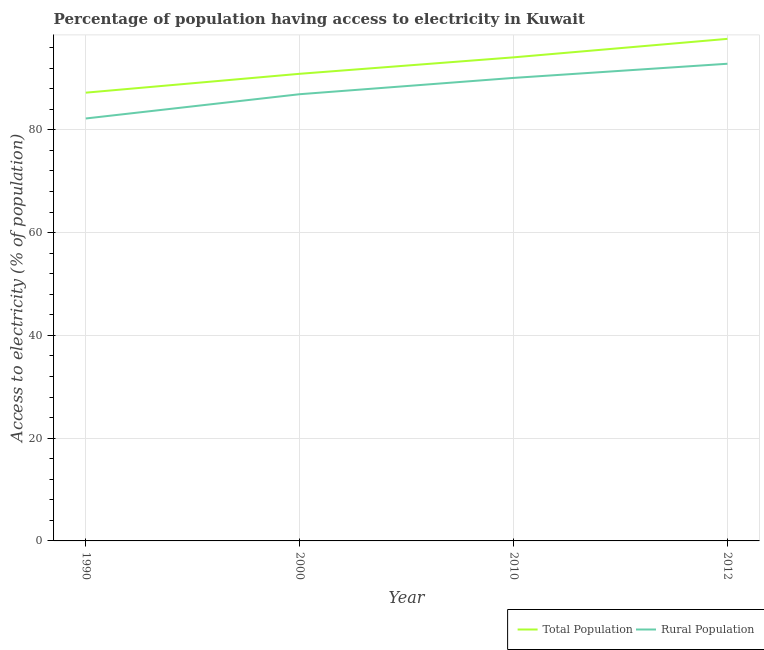Does the line corresponding to percentage of population having access to electricity intersect with the line corresponding to percentage of rural population having access to electricity?
Make the answer very short. No. Is the number of lines equal to the number of legend labels?
Offer a very short reply. Yes. What is the percentage of population having access to electricity in 2010?
Your answer should be very brief. 94.1. Across all years, what is the maximum percentage of rural population having access to electricity?
Offer a terse response. 92.85. Across all years, what is the minimum percentage of population having access to electricity?
Make the answer very short. 87.23. In which year was the percentage of population having access to electricity minimum?
Provide a short and direct response. 1990. What is the total percentage of population having access to electricity in the graph?
Offer a terse response. 369.92. What is the difference between the percentage of population having access to electricity in 1990 and that in 2010?
Offer a terse response. -6.87. What is the difference between the percentage of population having access to electricity in 2000 and the percentage of rural population having access to electricity in 2012?
Keep it short and to the point. -1.96. What is the average percentage of rural population having access to electricity per year?
Ensure brevity in your answer.  88.02. In the year 2000, what is the difference between the percentage of population having access to electricity and percentage of rural population having access to electricity?
Your answer should be compact. 3.97. What is the ratio of the percentage of population having access to electricity in 1990 to that in 2010?
Provide a short and direct response. 0.93. Is the percentage of rural population having access to electricity in 2000 less than that in 2010?
Offer a terse response. Yes. Is the difference between the percentage of population having access to electricity in 2010 and 2012 greater than the difference between the percentage of rural population having access to electricity in 2010 and 2012?
Make the answer very short. No. What is the difference between the highest and the second highest percentage of population having access to electricity?
Offer a very short reply. 3.6. What is the difference between the highest and the lowest percentage of rural population having access to electricity?
Give a very brief answer. 10.65. In how many years, is the percentage of population having access to electricity greater than the average percentage of population having access to electricity taken over all years?
Offer a terse response. 2. Is the percentage of rural population having access to electricity strictly greater than the percentage of population having access to electricity over the years?
Provide a succinct answer. No. How many lines are there?
Ensure brevity in your answer.  2. Does the graph contain any zero values?
Your answer should be compact. No. Does the graph contain grids?
Make the answer very short. Yes. How are the legend labels stacked?
Your answer should be compact. Horizontal. What is the title of the graph?
Make the answer very short. Percentage of population having access to electricity in Kuwait. What is the label or title of the Y-axis?
Offer a very short reply. Access to electricity (% of population). What is the Access to electricity (% of population) of Total Population in 1990?
Keep it short and to the point. 87.23. What is the Access to electricity (% of population) of Rural Population in 1990?
Make the answer very short. 82.2. What is the Access to electricity (% of population) of Total Population in 2000?
Make the answer very short. 90.9. What is the Access to electricity (% of population) in Rural Population in 2000?
Offer a very short reply. 86.93. What is the Access to electricity (% of population) in Total Population in 2010?
Offer a very short reply. 94.1. What is the Access to electricity (% of population) of Rural Population in 2010?
Ensure brevity in your answer.  90.1. What is the Access to electricity (% of population) in Total Population in 2012?
Make the answer very short. 97.7. What is the Access to electricity (% of population) in Rural Population in 2012?
Ensure brevity in your answer.  92.85. Across all years, what is the maximum Access to electricity (% of population) of Total Population?
Your response must be concise. 97.7. Across all years, what is the maximum Access to electricity (% of population) in Rural Population?
Offer a terse response. 92.85. Across all years, what is the minimum Access to electricity (% of population) of Total Population?
Provide a succinct answer. 87.23. Across all years, what is the minimum Access to electricity (% of population) in Rural Population?
Your answer should be very brief. 82.2. What is the total Access to electricity (% of population) of Total Population in the graph?
Offer a terse response. 369.92. What is the total Access to electricity (% of population) of Rural Population in the graph?
Your response must be concise. 352.08. What is the difference between the Access to electricity (% of population) of Total Population in 1990 and that in 2000?
Your answer should be compact. -3.67. What is the difference between the Access to electricity (% of population) in Rural Population in 1990 and that in 2000?
Provide a short and direct response. -4.72. What is the difference between the Access to electricity (% of population) of Total Population in 1990 and that in 2010?
Your answer should be very brief. -6.87. What is the difference between the Access to electricity (% of population) of Rural Population in 1990 and that in 2010?
Your answer should be compact. -7.9. What is the difference between the Access to electricity (% of population) in Total Population in 1990 and that in 2012?
Ensure brevity in your answer.  -10.47. What is the difference between the Access to electricity (% of population) of Rural Population in 1990 and that in 2012?
Keep it short and to the point. -10.65. What is the difference between the Access to electricity (% of population) of Total Population in 2000 and that in 2010?
Give a very brief answer. -3.2. What is the difference between the Access to electricity (% of population) of Rural Population in 2000 and that in 2010?
Offer a very short reply. -3.17. What is the difference between the Access to electricity (% of population) in Total Population in 2000 and that in 2012?
Make the answer very short. -6.8. What is the difference between the Access to electricity (% of population) in Rural Population in 2000 and that in 2012?
Your response must be concise. -5.93. What is the difference between the Access to electricity (% of population) of Total Population in 2010 and that in 2012?
Your answer should be compact. -3.6. What is the difference between the Access to electricity (% of population) in Rural Population in 2010 and that in 2012?
Provide a short and direct response. -2.75. What is the difference between the Access to electricity (% of population) in Total Population in 1990 and the Access to electricity (% of population) in Rural Population in 2000?
Your response must be concise. 0.3. What is the difference between the Access to electricity (% of population) of Total Population in 1990 and the Access to electricity (% of population) of Rural Population in 2010?
Give a very brief answer. -2.87. What is the difference between the Access to electricity (% of population) in Total Population in 1990 and the Access to electricity (% of population) in Rural Population in 2012?
Provide a succinct answer. -5.63. What is the difference between the Access to electricity (% of population) in Total Population in 2000 and the Access to electricity (% of population) in Rural Population in 2010?
Your answer should be compact. 0.8. What is the difference between the Access to electricity (% of population) in Total Population in 2000 and the Access to electricity (% of population) in Rural Population in 2012?
Provide a succinct answer. -1.96. What is the difference between the Access to electricity (% of population) in Total Population in 2010 and the Access to electricity (% of population) in Rural Population in 2012?
Your response must be concise. 1.25. What is the average Access to electricity (% of population) in Total Population per year?
Make the answer very short. 92.48. What is the average Access to electricity (% of population) of Rural Population per year?
Give a very brief answer. 88.02. In the year 1990, what is the difference between the Access to electricity (% of population) in Total Population and Access to electricity (% of population) in Rural Population?
Give a very brief answer. 5.02. In the year 2000, what is the difference between the Access to electricity (% of population) of Total Population and Access to electricity (% of population) of Rural Population?
Keep it short and to the point. 3.97. In the year 2012, what is the difference between the Access to electricity (% of population) in Total Population and Access to electricity (% of population) in Rural Population?
Ensure brevity in your answer.  4.84. What is the ratio of the Access to electricity (% of population) of Total Population in 1990 to that in 2000?
Make the answer very short. 0.96. What is the ratio of the Access to electricity (% of population) of Rural Population in 1990 to that in 2000?
Make the answer very short. 0.95. What is the ratio of the Access to electricity (% of population) of Total Population in 1990 to that in 2010?
Your answer should be compact. 0.93. What is the ratio of the Access to electricity (% of population) in Rural Population in 1990 to that in 2010?
Offer a very short reply. 0.91. What is the ratio of the Access to electricity (% of population) of Total Population in 1990 to that in 2012?
Provide a succinct answer. 0.89. What is the ratio of the Access to electricity (% of population) in Rural Population in 1990 to that in 2012?
Keep it short and to the point. 0.89. What is the ratio of the Access to electricity (% of population) of Rural Population in 2000 to that in 2010?
Your answer should be very brief. 0.96. What is the ratio of the Access to electricity (% of population) in Total Population in 2000 to that in 2012?
Provide a short and direct response. 0.93. What is the ratio of the Access to electricity (% of population) of Rural Population in 2000 to that in 2012?
Your response must be concise. 0.94. What is the ratio of the Access to electricity (% of population) of Total Population in 2010 to that in 2012?
Offer a very short reply. 0.96. What is the ratio of the Access to electricity (% of population) of Rural Population in 2010 to that in 2012?
Give a very brief answer. 0.97. What is the difference between the highest and the second highest Access to electricity (% of population) of Total Population?
Keep it short and to the point. 3.6. What is the difference between the highest and the second highest Access to electricity (% of population) of Rural Population?
Give a very brief answer. 2.75. What is the difference between the highest and the lowest Access to electricity (% of population) of Total Population?
Your answer should be compact. 10.47. What is the difference between the highest and the lowest Access to electricity (% of population) in Rural Population?
Offer a very short reply. 10.65. 